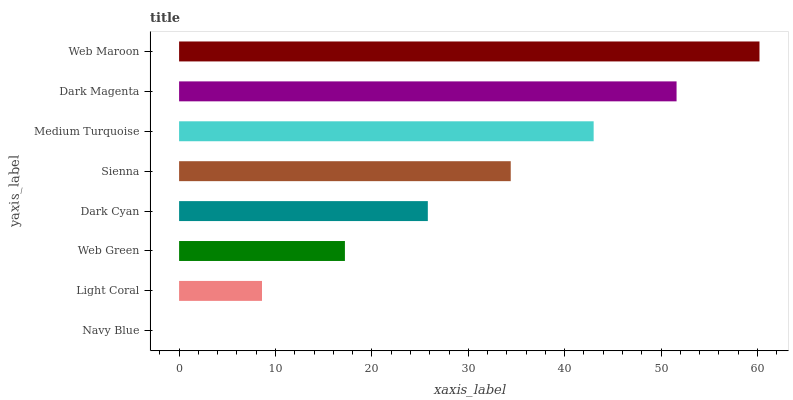Is Navy Blue the minimum?
Answer yes or no. Yes. Is Web Maroon the maximum?
Answer yes or no. Yes. Is Light Coral the minimum?
Answer yes or no. No. Is Light Coral the maximum?
Answer yes or no. No. Is Light Coral greater than Navy Blue?
Answer yes or no. Yes. Is Navy Blue less than Light Coral?
Answer yes or no. Yes. Is Navy Blue greater than Light Coral?
Answer yes or no. No. Is Light Coral less than Navy Blue?
Answer yes or no. No. Is Sienna the high median?
Answer yes or no. Yes. Is Dark Cyan the low median?
Answer yes or no. Yes. Is Dark Magenta the high median?
Answer yes or no. No. Is Dark Magenta the low median?
Answer yes or no. No. 